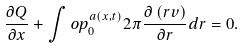<formula> <loc_0><loc_0><loc_500><loc_500>\frac { \partial Q } { \partial x } + \int o p _ { 0 } ^ { a \left ( x , t \right ) } 2 \pi \frac { \partial \left ( r v \right ) } { \partial r } d r = 0 .</formula> 